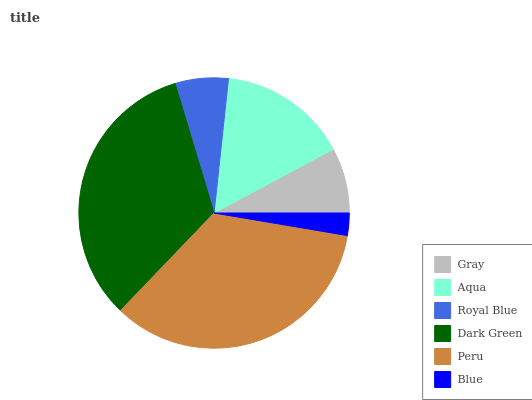Is Blue the minimum?
Answer yes or no. Yes. Is Peru the maximum?
Answer yes or no. Yes. Is Aqua the minimum?
Answer yes or no. No. Is Aqua the maximum?
Answer yes or no. No. Is Aqua greater than Gray?
Answer yes or no. Yes. Is Gray less than Aqua?
Answer yes or no. Yes. Is Gray greater than Aqua?
Answer yes or no. No. Is Aqua less than Gray?
Answer yes or no. No. Is Aqua the high median?
Answer yes or no. Yes. Is Gray the low median?
Answer yes or no. Yes. Is Blue the high median?
Answer yes or no. No. Is Royal Blue the low median?
Answer yes or no. No. 